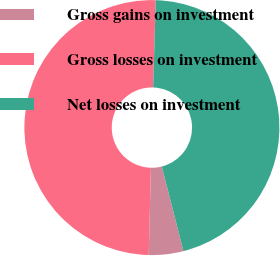<chart> <loc_0><loc_0><loc_500><loc_500><pie_chart><fcel>Gross gains on investment<fcel>Gross losses on investment<fcel>Net losses on investment<nl><fcel>4.37%<fcel>50.09%<fcel>45.54%<nl></chart> 